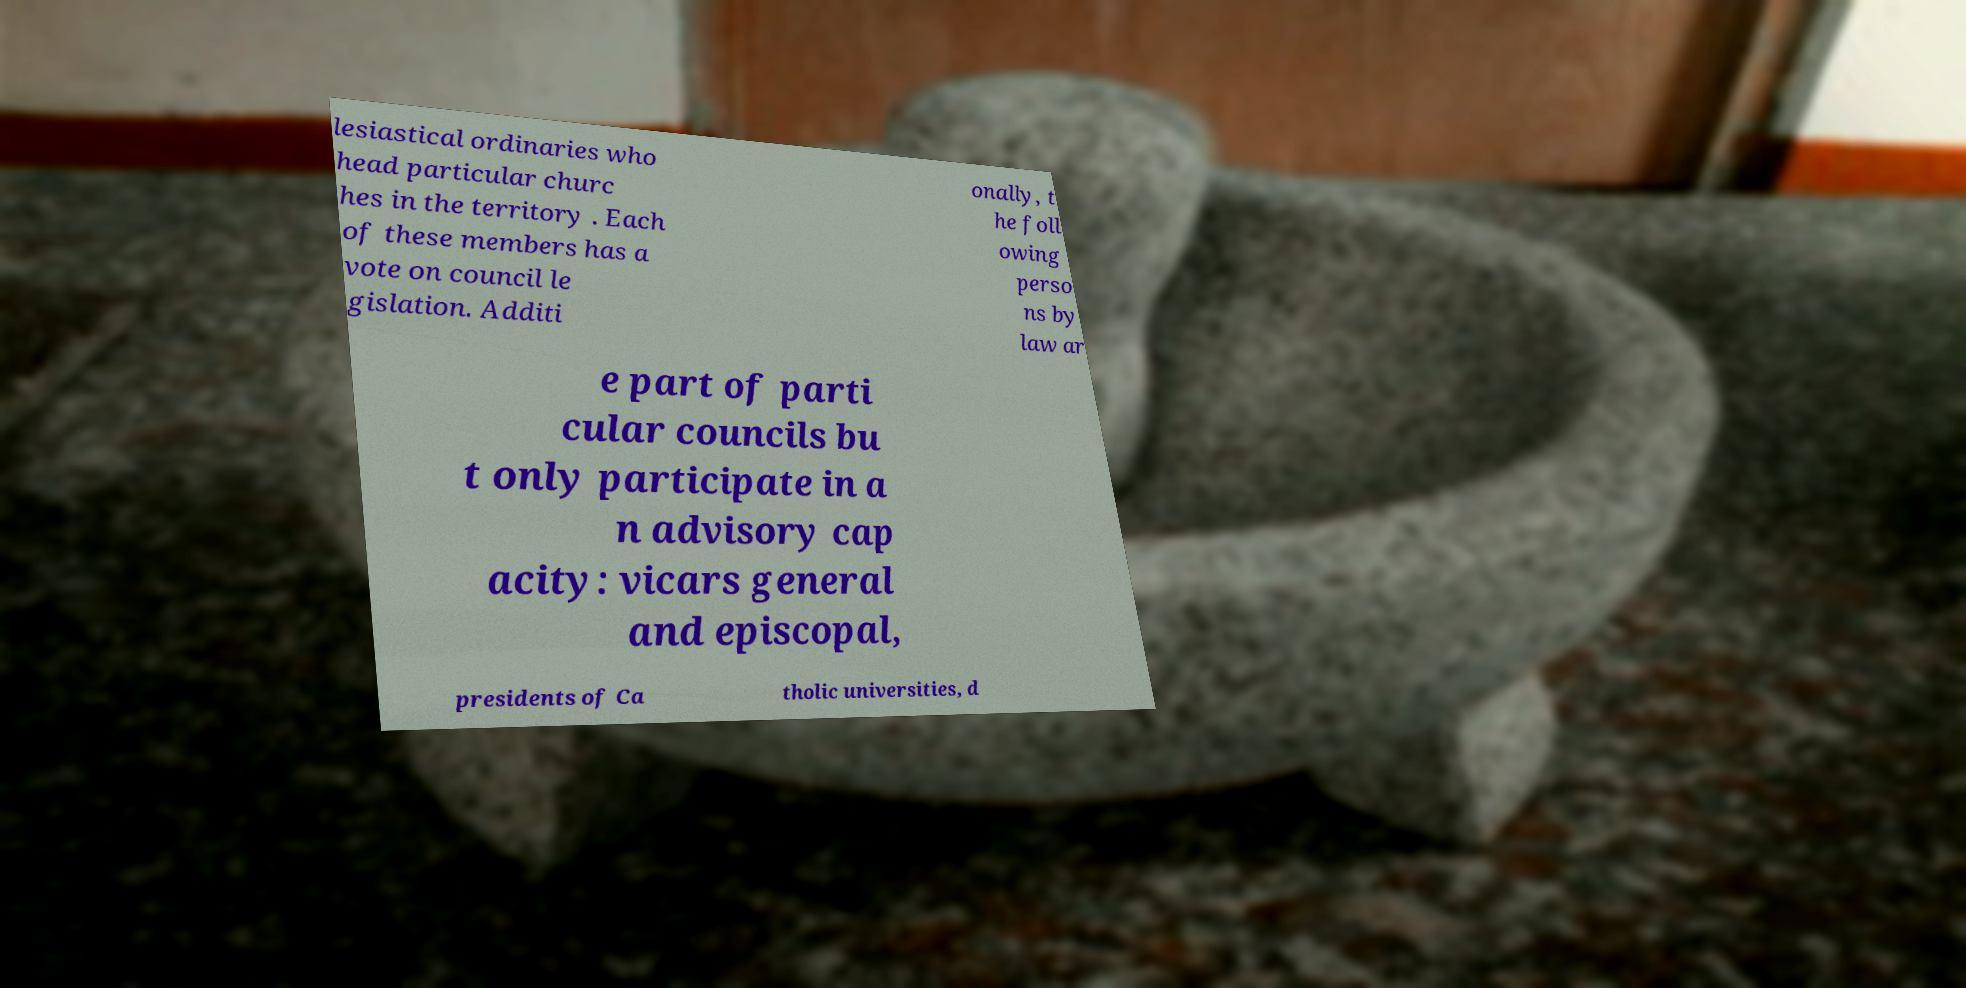I need the written content from this picture converted into text. Can you do that? lesiastical ordinaries who head particular churc hes in the territory . Each of these members has a vote on council le gislation. Additi onally, t he foll owing perso ns by law ar e part of parti cular councils bu t only participate in a n advisory cap acity: vicars general and episcopal, presidents of Ca tholic universities, d 